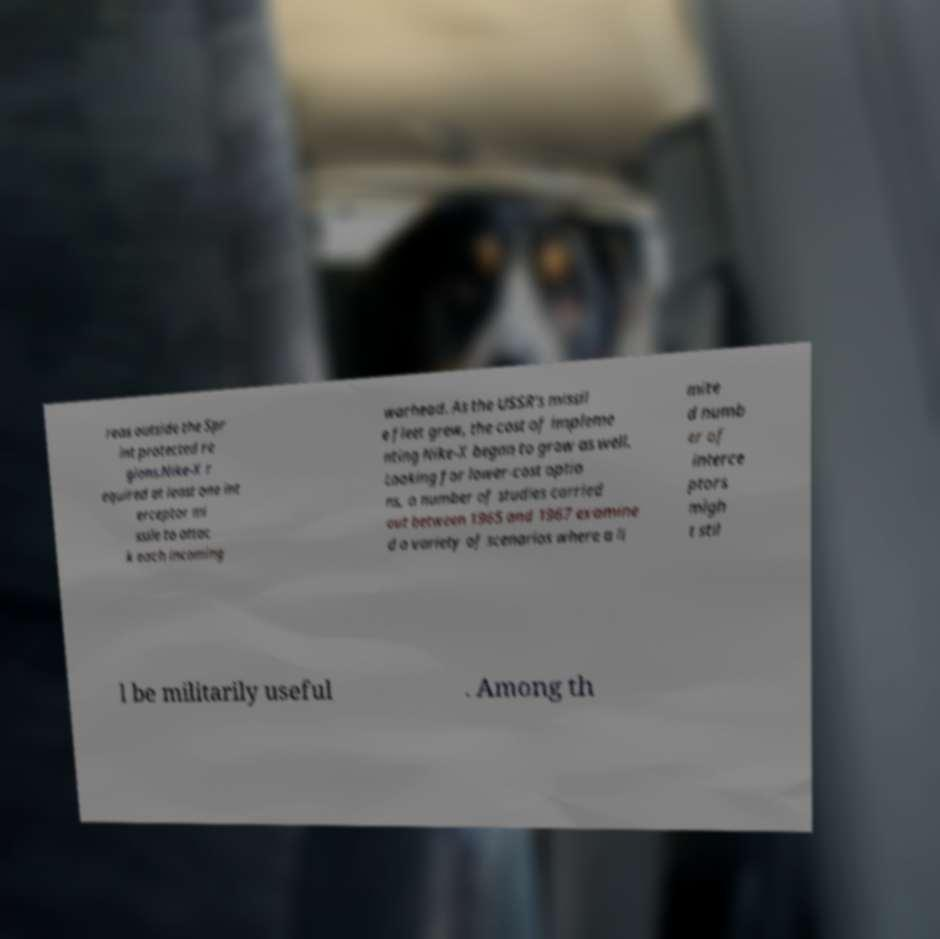For documentation purposes, I need the text within this image transcribed. Could you provide that? reas outside the Spr int protected re gions.Nike-X r equired at least one int erceptor mi ssile to attac k each incoming warhead. As the USSR's missil e fleet grew, the cost of impleme nting Nike-X began to grow as well. Looking for lower-cost optio ns, a number of studies carried out between 1965 and 1967 examine d a variety of scenarios where a li mite d numb er of interce ptors migh t stil l be militarily useful . Among th 